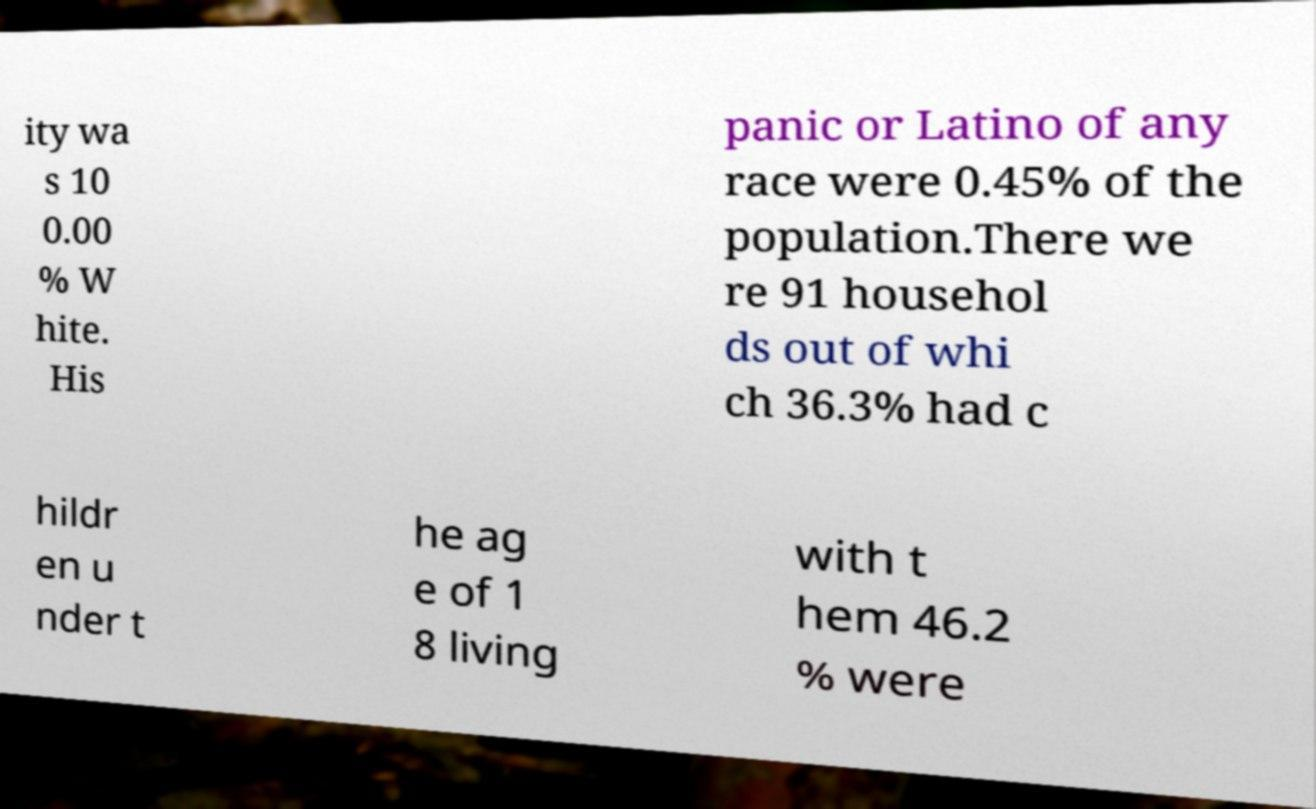Can you accurately transcribe the text from the provided image for me? ity wa s 10 0.00 % W hite. His panic or Latino of any race were 0.45% of the population.There we re 91 househol ds out of whi ch 36.3% had c hildr en u nder t he ag e of 1 8 living with t hem 46.2 % were 